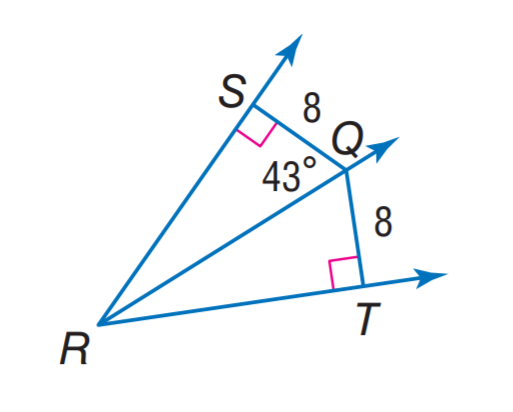Question: Find m \angle T Q R.
Choices:
A. 8
B. 34
C. 43
D. 44
Answer with the letter. Answer: C 